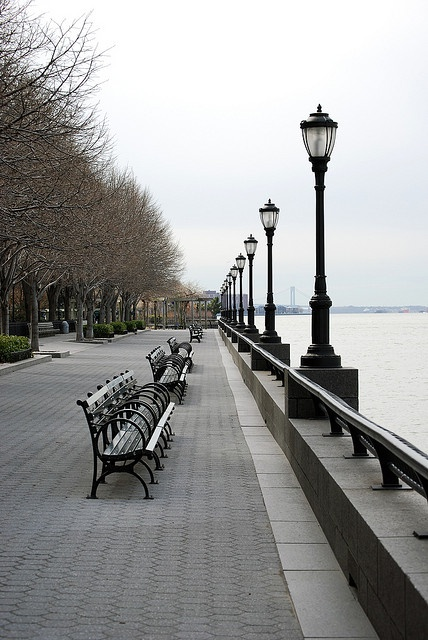Describe the objects in this image and their specific colors. I can see bench in gray, black, darkgray, and lightgray tones, bench in gray, black, darkgray, and lightgray tones, bench in gray, black, darkgray, and lightgray tones, bench in gray, black, and darkgray tones, and bench in gray, black, darkgray, and lightgray tones in this image. 